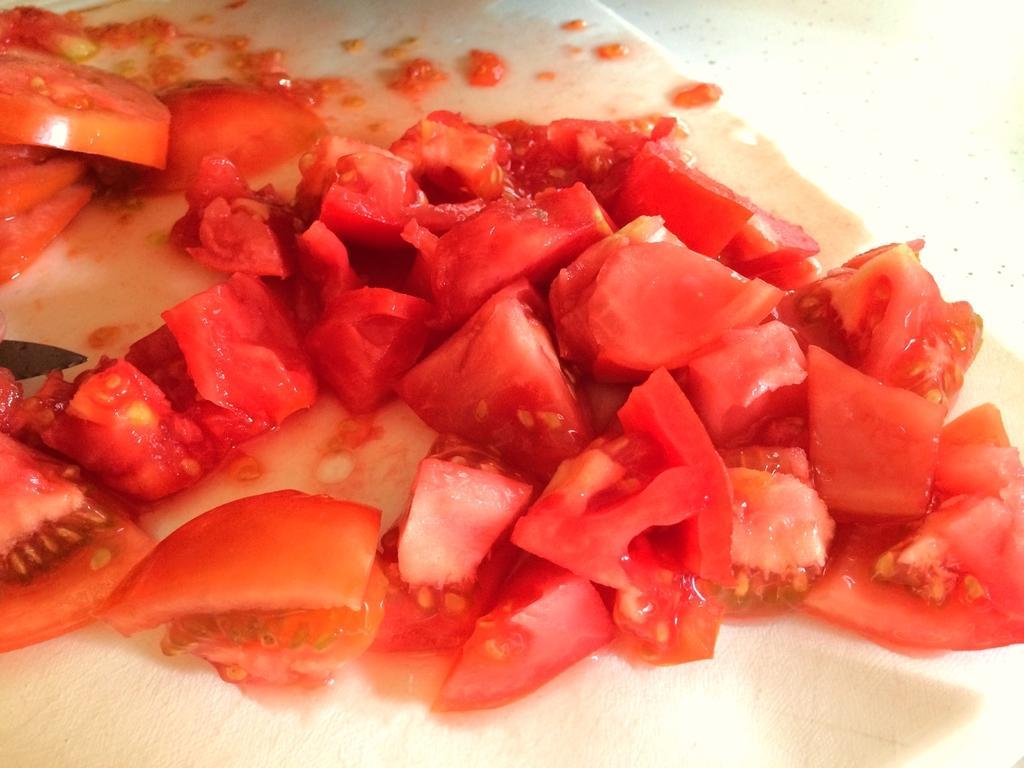In one or two sentences, can you explain what this image depicts? This is the picture of some chopped tomatoes on the white color thing. 